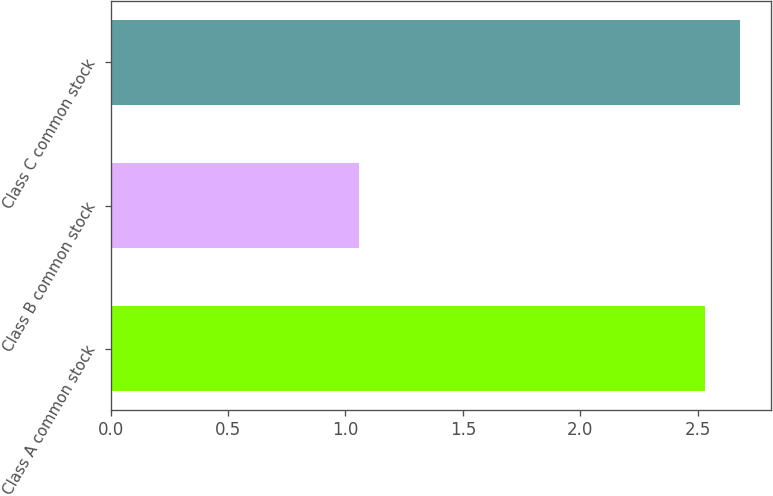<chart> <loc_0><loc_0><loc_500><loc_500><bar_chart><fcel>Class A common stock<fcel>Class B common stock<fcel>Class C common stock<nl><fcel>2.53<fcel>1.06<fcel>2.68<nl></chart> 